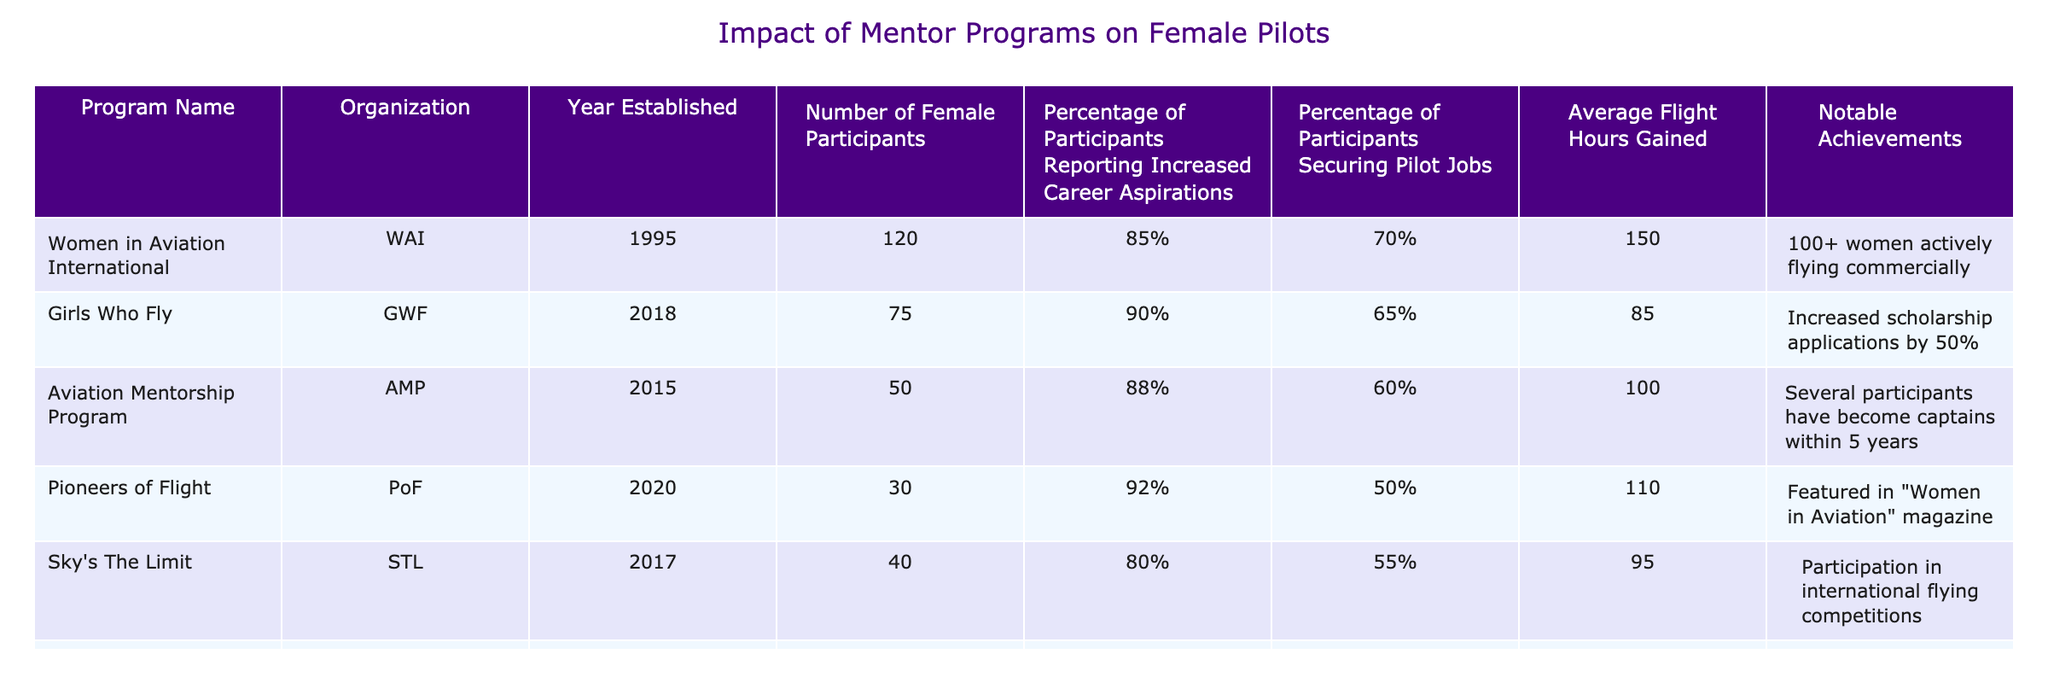What is the organization that established the "Women in Aviation International" program? The table lists "Women in Aviation International" under the "Program Name" column and the corresponding organization is "WAI" as stated in the same row.
Answer: WAI How many female participants are in the "Girls Who Fly" program? The "Girls Who Fly" program has 75 female participants as noted in the "Number of Female Participants" column for that program.
Answer: 75 What is the average flight hours gained by the participants in the "Aviation Mentorship Program"? The "Average Flight Hours Gained" for the "Aviation Mentorship Program" is 100 as shown in the corresponding row for that program.
Answer: 100 Which program has the highest percentage of participants reporting increased career aspirations? Upon reviewing the "Percentage of Participants Reporting Increased Career Aspirations" column, "Girls Who Fly" has the highest percentage at 90%.
Answer: Girls Who Fly What is the total number of notable achievements across all the programs listed? By examining the "Notable Achievements" column for each program, the total number of notable achievements is counted as follows: "100+ women", "Increased scholarship applications", "Several participants", "Featured in magazine", "Participation in competitions", "Collaboration with airlines" which amounts to 6 distinct achievements.
Answer: 6 Did the "Sky's The Limit" program have a higher percentage of securing pilot jobs than the "Pioneers of Flight" program? In the table, "Sky's The Limit" has a percentage of 55% for securing pilot jobs while "Pioneers of Flight" has 50%. Since 55% is greater than 50%, the answer is yes.
Answer: Yes What is the percentage difference in participants reporting increased career aspirations between "Aviation Mentorship Program" and "Flying Forward"? The percentage for "Aviation Mentorship Program" is 88% and for "Flying Forward" it is 86%, so to find the difference: 88% - 86% = 2%.
Answer: 2% Which program established most recently and how many female participants does it have? The most recently established program is "Pioneers of Flight" which was created in 2020, and it has 30 female participants as indicated in the respective columns.
Answer: Pioneers of Flight, 30 How many programs have a percentage of participants securing pilot jobs of 60% or greater? By counting the "Percentage of Participants Securing Pilot Jobs" column, "Women in Aviation International" (70%), "Aviation Mentorship Program" (60%), and "Flying Forward" (68%) exceed 60%. Thus, there are 3 programs that meet this criteria.
Answer: 3 Which two programs have notably increased scholarship applications and collaboration with major airlines, respectively? The "Girls Who Fly" program is noted for increasing scholarship applications by 50%, while "Flying Forward" involved collaboration with major airlines for job placements as per their respective notable achievements.
Answer: Girls Who Fly, Flying Forward 